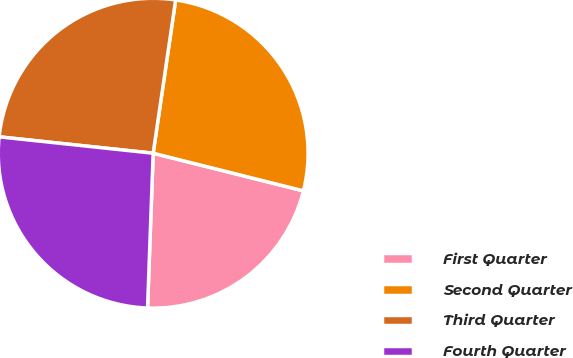Convert chart. <chart><loc_0><loc_0><loc_500><loc_500><pie_chart><fcel>First Quarter<fcel>Second Quarter<fcel>Third Quarter<fcel>Fourth Quarter<nl><fcel>21.67%<fcel>26.59%<fcel>25.63%<fcel>26.11%<nl></chart> 